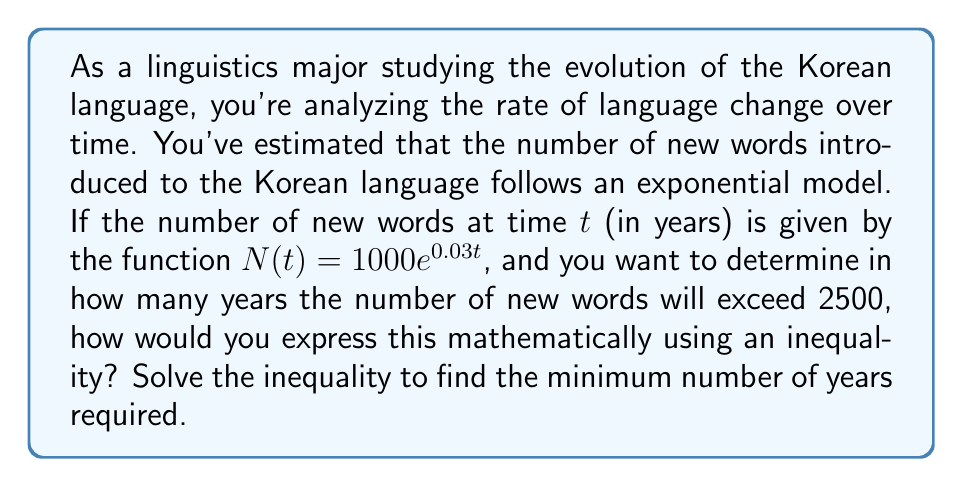What is the answer to this math problem? To solve this problem, we'll follow these steps:

1) We want to find when $N(t)$ exceeds 2500. This can be expressed as an inequality:

   $N(t) > 2500$

2) Substituting the given function:

   $1000e^{0.03t} > 2500$

3) Divide both sides by 1000:

   $e^{0.03t} > 2.5$

4) Take the natural logarithm of both sides. Since $\ln$ is an increasing function, the inequality direction remains the same:

   $\ln(e^{0.03t}) > \ln(2.5)$

5) Simplify the left side using the property of logarithms:

   $0.03t > \ln(2.5)$

6) Divide both sides by 0.03:

   $t > \frac{\ln(2.5)}{0.03}$

7) Calculate the right side:

   $t > 30.57$

8) Since $t$ represents years, we need to round up to the nearest whole number:

   $t \geq 31$

Therefore, it will take at least 31 years for the number of new words to exceed 2500.
Answer: The inequality is $1000e^{0.03t} > 2500$, and the solution is $t \geq 31$ years. 